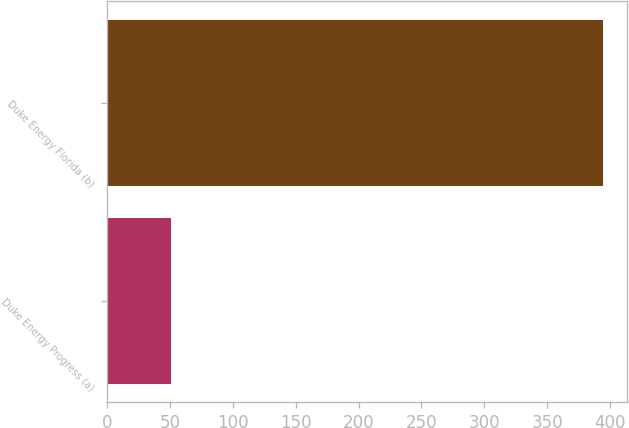Convert chart to OTSL. <chart><loc_0><loc_0><loc_500><loc_500><bar_chart><fcel>Duke Energy Progress (a)<fcel>Duke Energy Florida (b)<nl><fcel>51<fcel>394<nl></chart> 